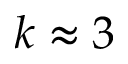Convert formula to latex. <formula><loc_0><loc_0><loc_500><loc_500>k \approx 3</formula> 